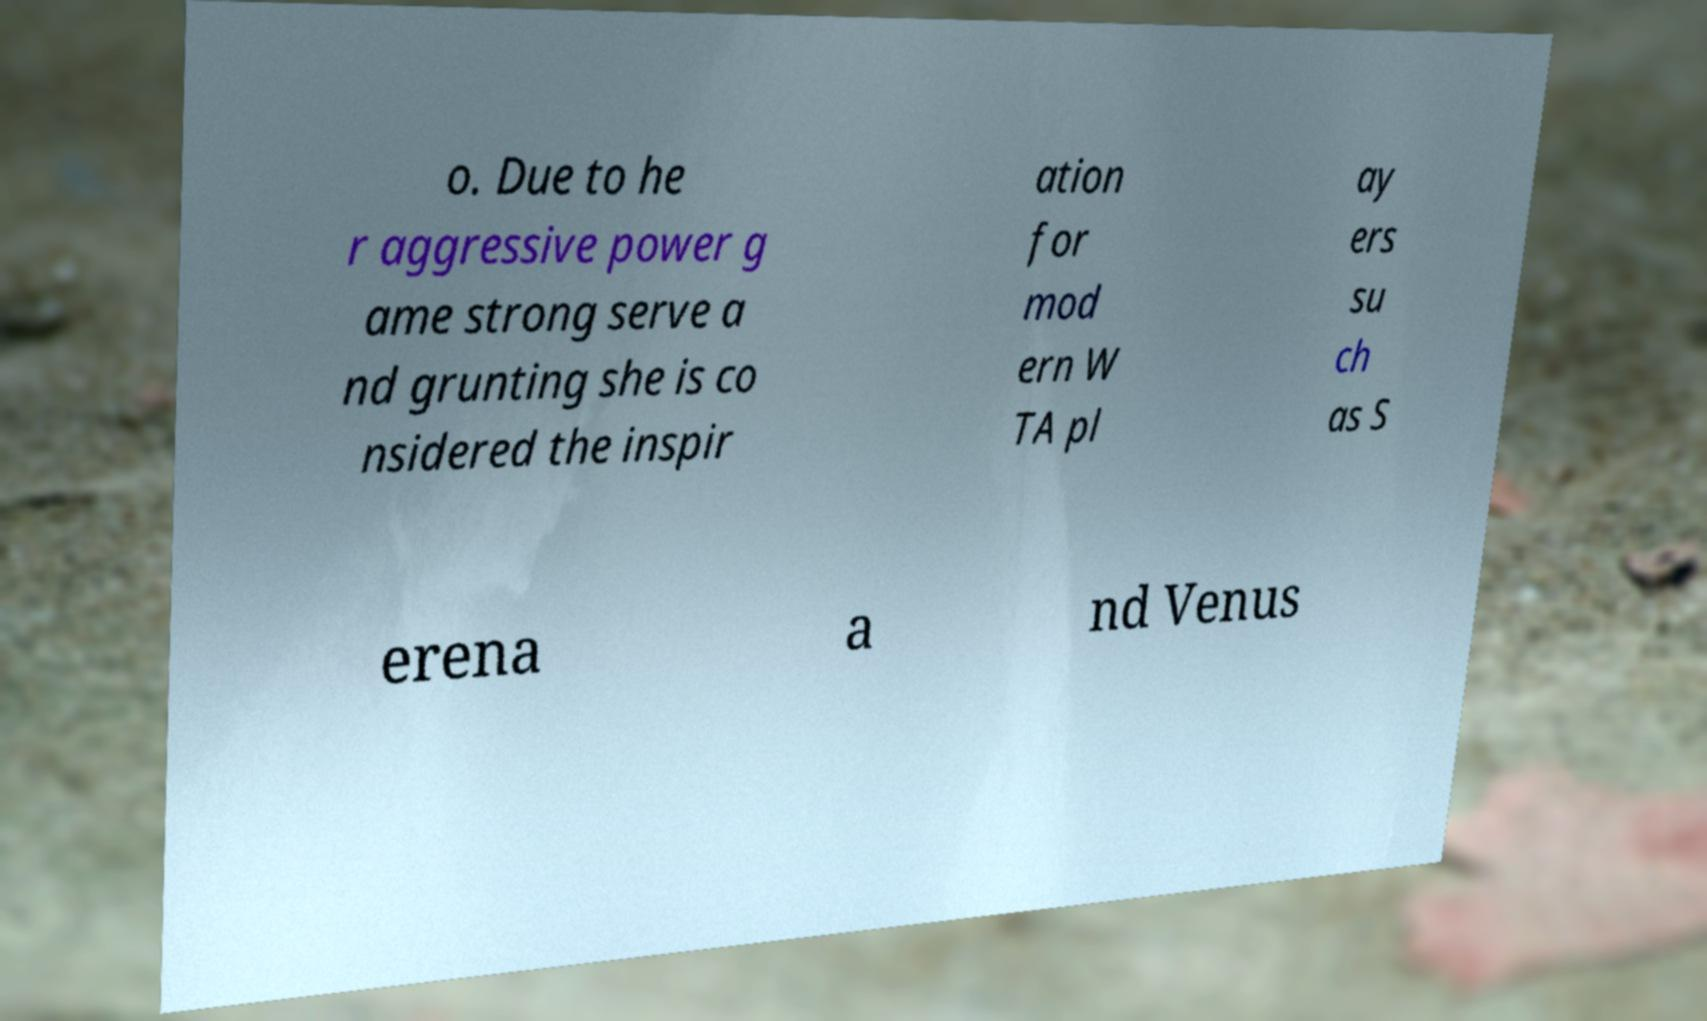For documentation purposes, I need the text within this image transcribed. Could you provide that? o. Due to he r aggressive power g ame strong serve a nd grunting she is co nsidered the inspir ation for mod ern W TA pl ay ers su ch as S erena a nd Venus 